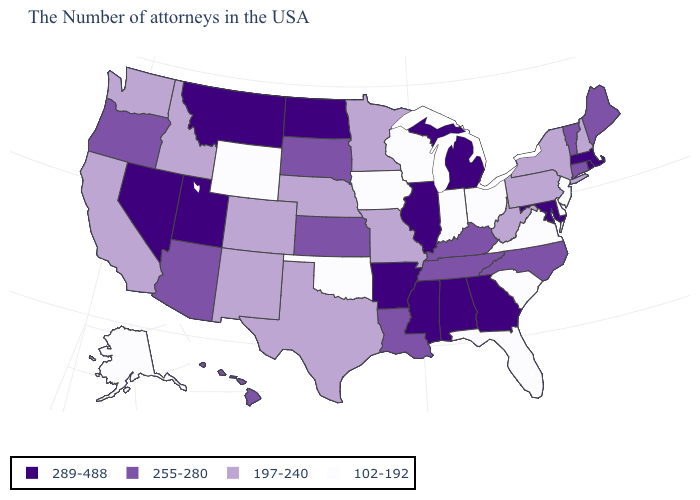Does Wyoming have a lower value than New Mexico?
Quick response, please. Yes. Is the legend a continuous bar?
Keep it brief. No. Name the states that have a value in the range 197-240?
Be succinct. New Hampshire, New York, Pennsylvania, West Virginia, Missouri, Minnesota, Nebraska, Texas, Colorado, New Mexico, Idaho, California, Washington. What is the value of Connecticut?
Short answer required. 255-280. Does Alabama have the same value as North Carolina?
Be succinct. No. Does Oregon have the lowest value in the West?
Keep it brief. No. Does Nebraska have the lowest value in the MidWest?
Answer briefly. No. What is the value of Wisconsin?
Quick response, please. 102-192. Does Oklahoma have the lowest value in the South?
Concise answer only. Yes. What is the highest value in the USA?
Quick response, please. 289-488. Which states have the lowest value in the USA?
Write a very short answer. New Jersey, Delaware, Virginia, South Carolina, Ohio, Florida, Indiana, Wisconsin, Iowa, Oklahoma, Wyoming, Alaska. Which states have the highest value in the USA?
Keep it brief. Massachusetts, Rhode Island, Maryland, Georgia, Michigan, Alabama, Illinois, Mississippi, Arkansas, North Dakota, Utah, Montana, Nevada. Among the states that border Minnesota , does North Dakota have the highest value?
Keep it brief. Yes. What is the value of Mississippi?
Give a very brief answer. 289-488. Does the map have missing data?
Answer briefly. No. 